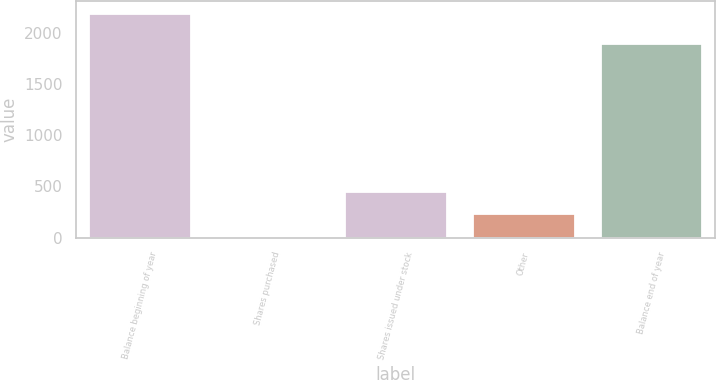Convert chart to OTSL. <chart><loc_0><loc_0><loc_500><loc_500><bar_chart><fcel>Balance beginning of year<fcel>Shares purchased<fcel>Shares issued under stock<fcel>Other<fcel>Balance end of year<nl><fcel>2197<fcel>20<fcel>455.4<fcel>237.7<fcel>1897<nl></chart> 